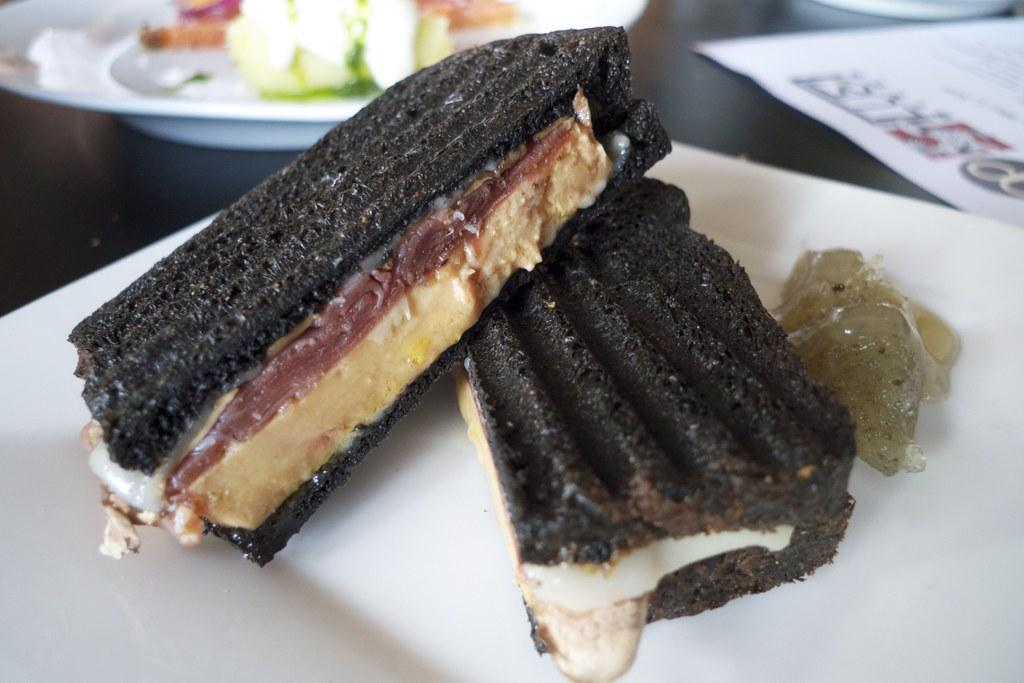What is the main subject in the center of the image? There is food on a plate in the center of the image. What else can be seen on the right side of the image? There is an object on the right side of the image. What is the color of the object on the right side of the image? The object is white in color. How many oranges are floating in the ocean in the image? There are no oranges or ocean present in the image. 